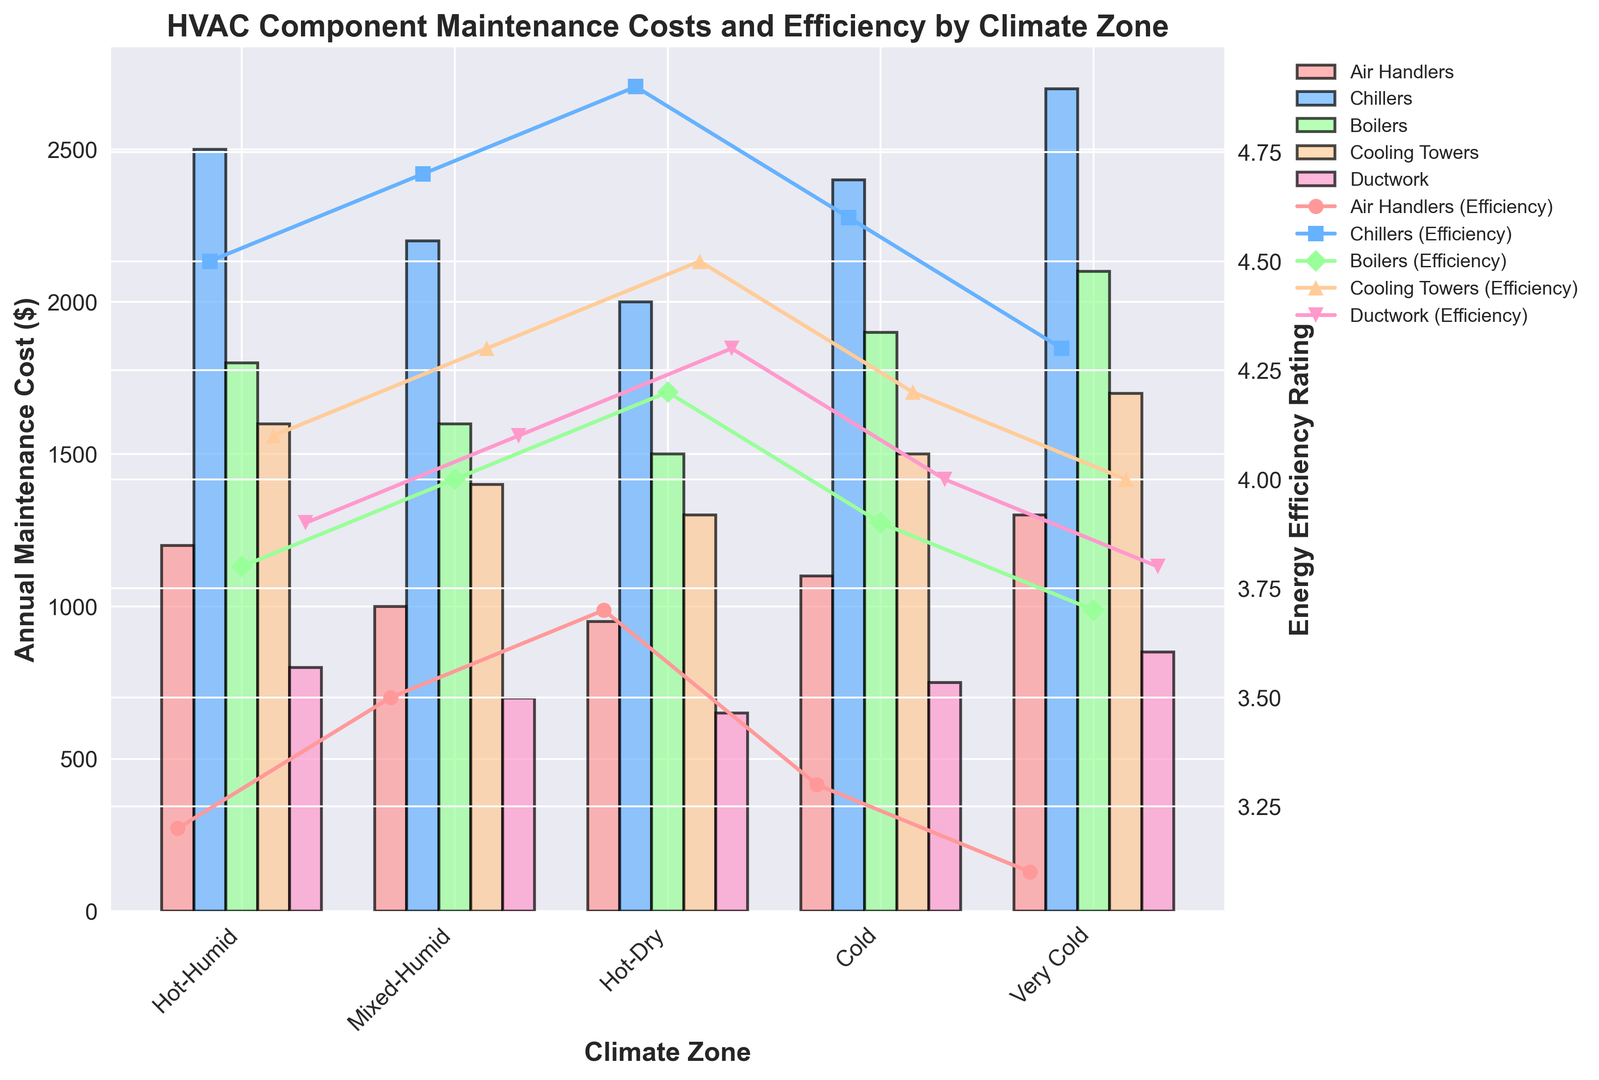Which HVAC component has the highest maintenance cost in the Very Cold climate zone? In the Very Cold climate zone, locate the highest bar among all components. The Chillers have the highest bar.
Answer: Chillers What's the average energy efficiency rating for Boilers across all climate zones? Sum up the energy efficiency ratings of Boilers across all climate zones: (3.8 + 4.0 + 4.2 + 3.9 + 3.7) = 19.6. Divide by the number of climate zones: 19.6 / 5 = 3.92
Answer: 3.92 Does the Hot-Dry climate zone have a lower maintenance cost for Cooling Towers compared to Mixed-Humid climate zone? Compare the heights of the Cooling Towers bars in Hot-Dry and Mixed-Humid climate zones. The bar in Hot-Dry is shorter.
Answer: Yes Which component shows the highest energy efficiency rating in the Hot-Humid climate zone? Look at the markers representing energy efficiency in the Hot-Humid climate zone. The Chillers have the highest marker.
Answer: Chillers What is the total annual maintenance cost for Ductwork across all climate zones? Sum up the maintenance costs for Ductwork across all climate zones: 800 + 700 + 650 + 750 + 850 = 3750
Answer: 3750 Compare the maintenance costs of Air Handlers and Boilers in the Cold climate zone. Which one is lower? Check the heights of the bars for Air Handlers and Boilers in the Cold climate zone. The Air Handlers bar is shorter.
Answer: Air Handlers Is there a component that has both the highest energy efficiency and the highest maintenance cost in a single climate zone? For each climate zone, compare the highest bar with its corresponding marker. In the Very Cold zone, Chillers have both the highest maintenance cost and highest efficiency.
Answer: Yes, Chillers in the Very Cold zone Which climate zone has the lowest energy efficiency rating for Air Handlers? Look at the markers for Air Handlers in each climate zone. The Very Cold climate zone has the lowest marker.
Answer: Very Cold What is the difference in maintenance costs between Chillers and Cooling Towers in the Mixed-Humid climate zone? Subtract the maintenance cost of Cooling Towers from that of Chillers in the Mixed-Humid zone: 2200 - 1400 = 800
Answer: 800 